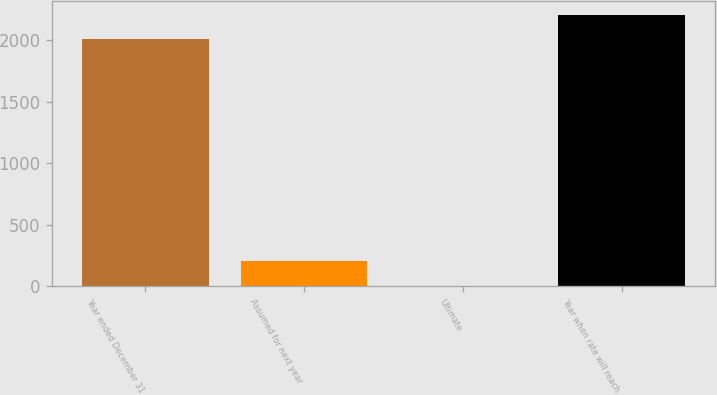Convert chart to OTSL. <chart><loc_0><loc_0><loc_500><loc_500><bar_chart><fcel>Year ended December 31<fcel>Assumed for next year<fcel>Ultimate<fcel>Year when rate will reach<nl><fcel>2005<fcel>205.7<fcel>5<fcel>2205.7<nl></chart> 